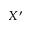Convert formula to latex. <formula><loc_0><loc_0><loc_500><loc_500>X ^ { \prime }</formula> 